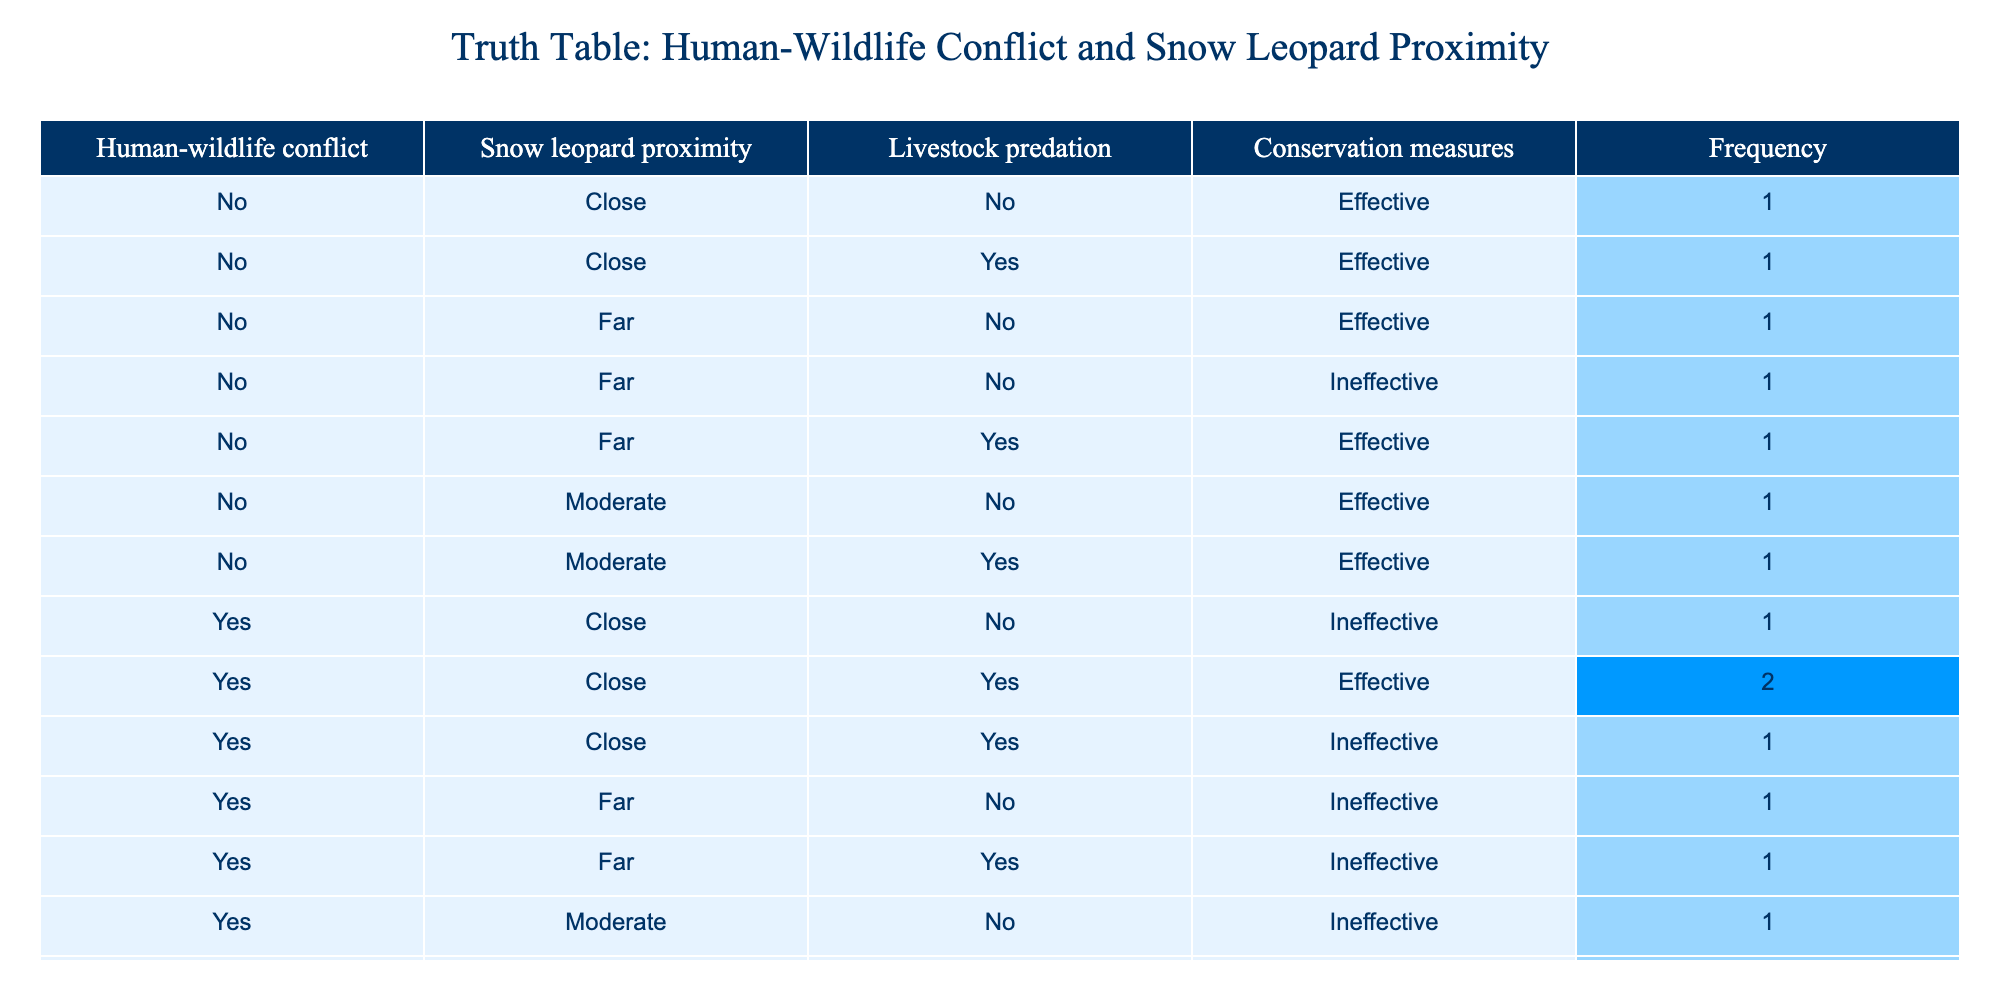What is the frequency of incidents where human-wildlife conflict occurs with snow leopards in close proximity? From the table, we can look at all instances where "Human-wildlife conflict" is "Yes" and "Snow leopard proximity" is "Close". There are 3 occurrences that meet this condition: (Yes, Close, Yes, Ineffective), (Yes, Close, Yes, Effective), and (Yes, Close, No, Ineffective). Therefore, the frequency is 3.
Answer: 3 What proportion of conflicts with livestock predation are associated with ineffective conservation measures? We need to calculate the total instances of livestock predation where conservation measures are "Ineffective". From the table, the relevant rows are: (Yes, Close, Yes, Ineffective), (Yes, Moderate, Yes, Ineffective), (Yes, Far, Yes, Ineffective), and (Yes, Close, No, Ineffective). This results in 4 rows with ineffective measures out of a total of 8 with livestock predation, providing a proportion of 4/8 = 0.5 or 50%.
Answer: 50% Are there any instances where there is no livestock predation and human-wildlife conflict occurs? We check the table for cases where "Livestock predation" is "No" and "Human-wildlife conflict" is "Yes". There are 0 cases that satisfy both conditions, as all "No" instances of livestock predation have "Human-wildlife conflict" marked as "No".
Answer: No What is the average distance of snow leopard proximity in incidents where human-wildlife conflict occurs? To find the average, we first identify all cases where "Human-wildlife conflict" is "Yes". The proximities are: Close (0), Moderate (1), Far (2), and we have three "Close", two "Moderate" and two "Far": So calculating gives us: (3 * 0 + 2 * 1 + 2 * 2)/7 = (0 + 2 + 4)/7 = 6/7 = approximately 0.86.
Answer: 0.86 Is there an effective conservation measure in cases of human-wildlife conflict and close proximity? By examining the table, we identify combinations of "Human-wildlife conflict" as "Yes", "Snow leopard proximity" as "Close" and look for "Effective" conservation measures. There is one case where conservation measures are effective: (Yes, Close, Yes, Effective).
Answer: Yes 